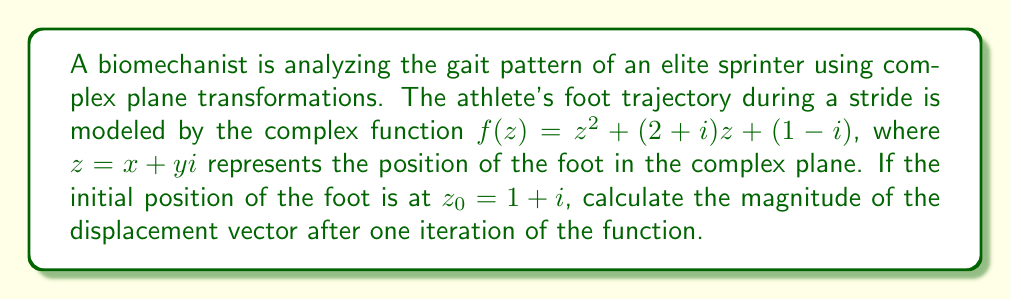What is the answer to this math problem? To solve this problem, we'll follow these steps:

1) First, we need to calculate $f(z_0)$:
   $f(z_0) = (1+i)^2 + (2+i)(1+i) + (1-i)$

2) Let's expand $(1+i)^2$:
   $(1+i)^2 = 1^2 + 2i - 1 = 2i$

3) Now, let's calculate $(2+i)(1+i)$:
   $(2+i)(1+i) = 2 + 2i + i + i^2 = 2 + 3i - 1 = 1 + 3i$

4) Putting it all together:
   $f(z_0) = 2i + (1+3i) + (1-i) = 2 + 4i$

5) The displacement vector is the difference between the final and initial positions:
   $\vec{v} = f(z_0) - z_0 = (2+4i) - (1+i) = 1 + 3i$

6) The magnitude of the displacement vector is given by the absolute value of the complex number:
   $|\vec{v}| = |1 + 3i| = \sqrt{1^2 + 3^2} = \sqrt{10}$

Therefore, the magnitude of the displacement vector after one iteration is $\sqrt{10}$.
Answer: $\sqrt{10}$ 